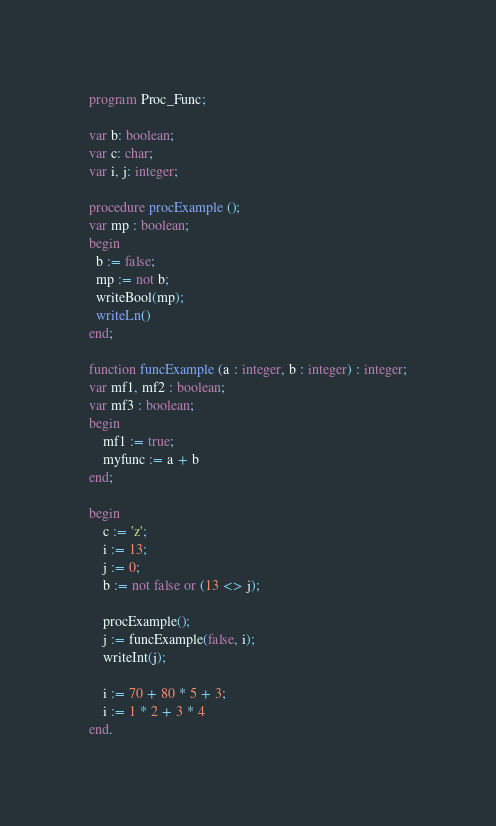Convert code to text. <code><loc_0><loc_0><loc_500><loc_500><_Pascal_>program Proc_Func;

var b: boolean;
var c: char;
var i, j: integer;

procedure procExample ();
var mp : boolean;
begin
  b := false;
  mp := not b;
  writeBool(mp);
  writeLn()
end;

function funcExample (a : integer, b : integer) : integer;
var mf1, mf2 : boolean;
var mf3 : boolean;
begin
    mf1 := true;
    myfunc := a + b
end;

begin
    c := 'z';
    i := 13;
    j := 0;
    b := not false or (13 <> j);

    procExample();
    j := funcExample(false, i);
    writeInt(j);

    i := 70 + 80 * 5 + 3;
    i := 1 * 2 + 3 * 4
end.</code> 